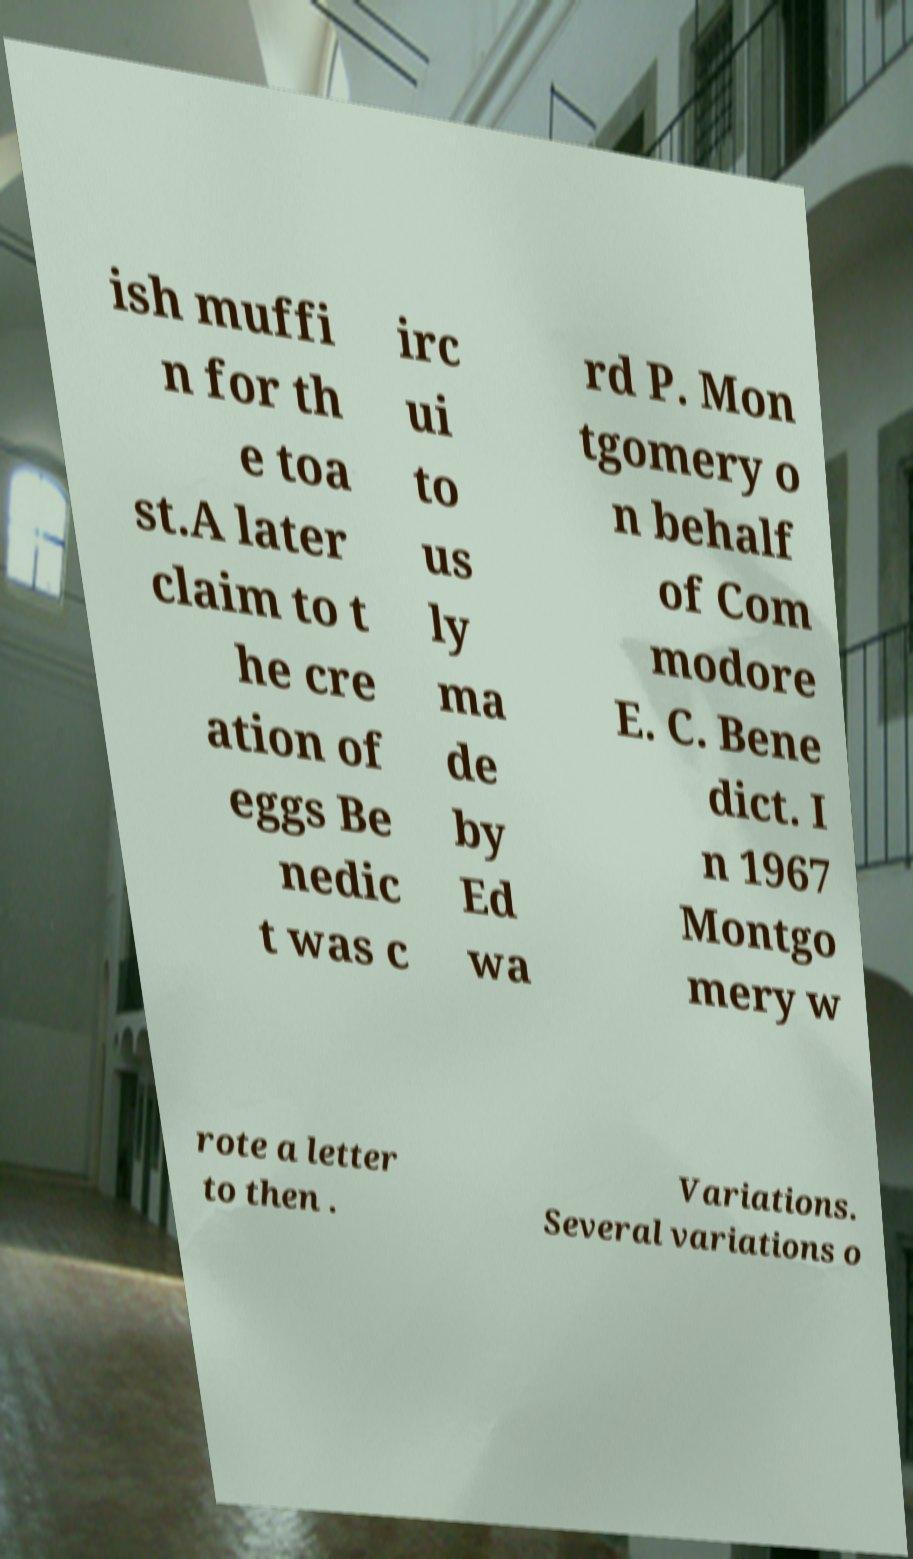There's text embedded in this image that I need extracted. Can you transcribe it verbatim? ish muffi n for th e toa st.A later claim to t he cre ation of eggs Be nedic t was c irc ui to us ly ma de by Ed wa rd P. Mon tgomery o n behalf of Com modore E. C. Bene dict. I n 1967 Montgo mery w rote a letter to then . Variations. Several variations o 